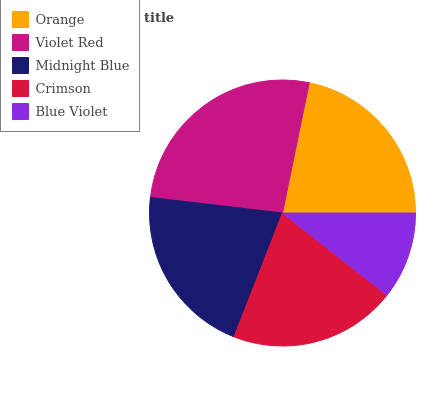Is Blue Violet the minimum?
Answer yes or no. Yes. Is Violet Red the maximum?
Answer yes or no. Yes. Is Midnight Blue the minimum?
Answer yes or no. No. Is Midnight Blue the maximum?
Answer yes or no. No. Is Violet Red greater than Midnight Blue?
Answer yes or no. Yes. Is Midnight Blue less than Violet Red?
Answer yes or no. Yes. Is Midnight Blue greater than Violet Red?
Answer yes or no. No. Is Violet Red less than Midnight Blue?
Answer yes or no. No. Is Midnight Blue the high median?
Answer yes or no. Yes. Is Midnight Blue the low median?
Answer yes or no. Yes. Is Violet Red the high median?
Answer yes or no. No. Is Blue Violet the low median?
Answer yes or no. No. 